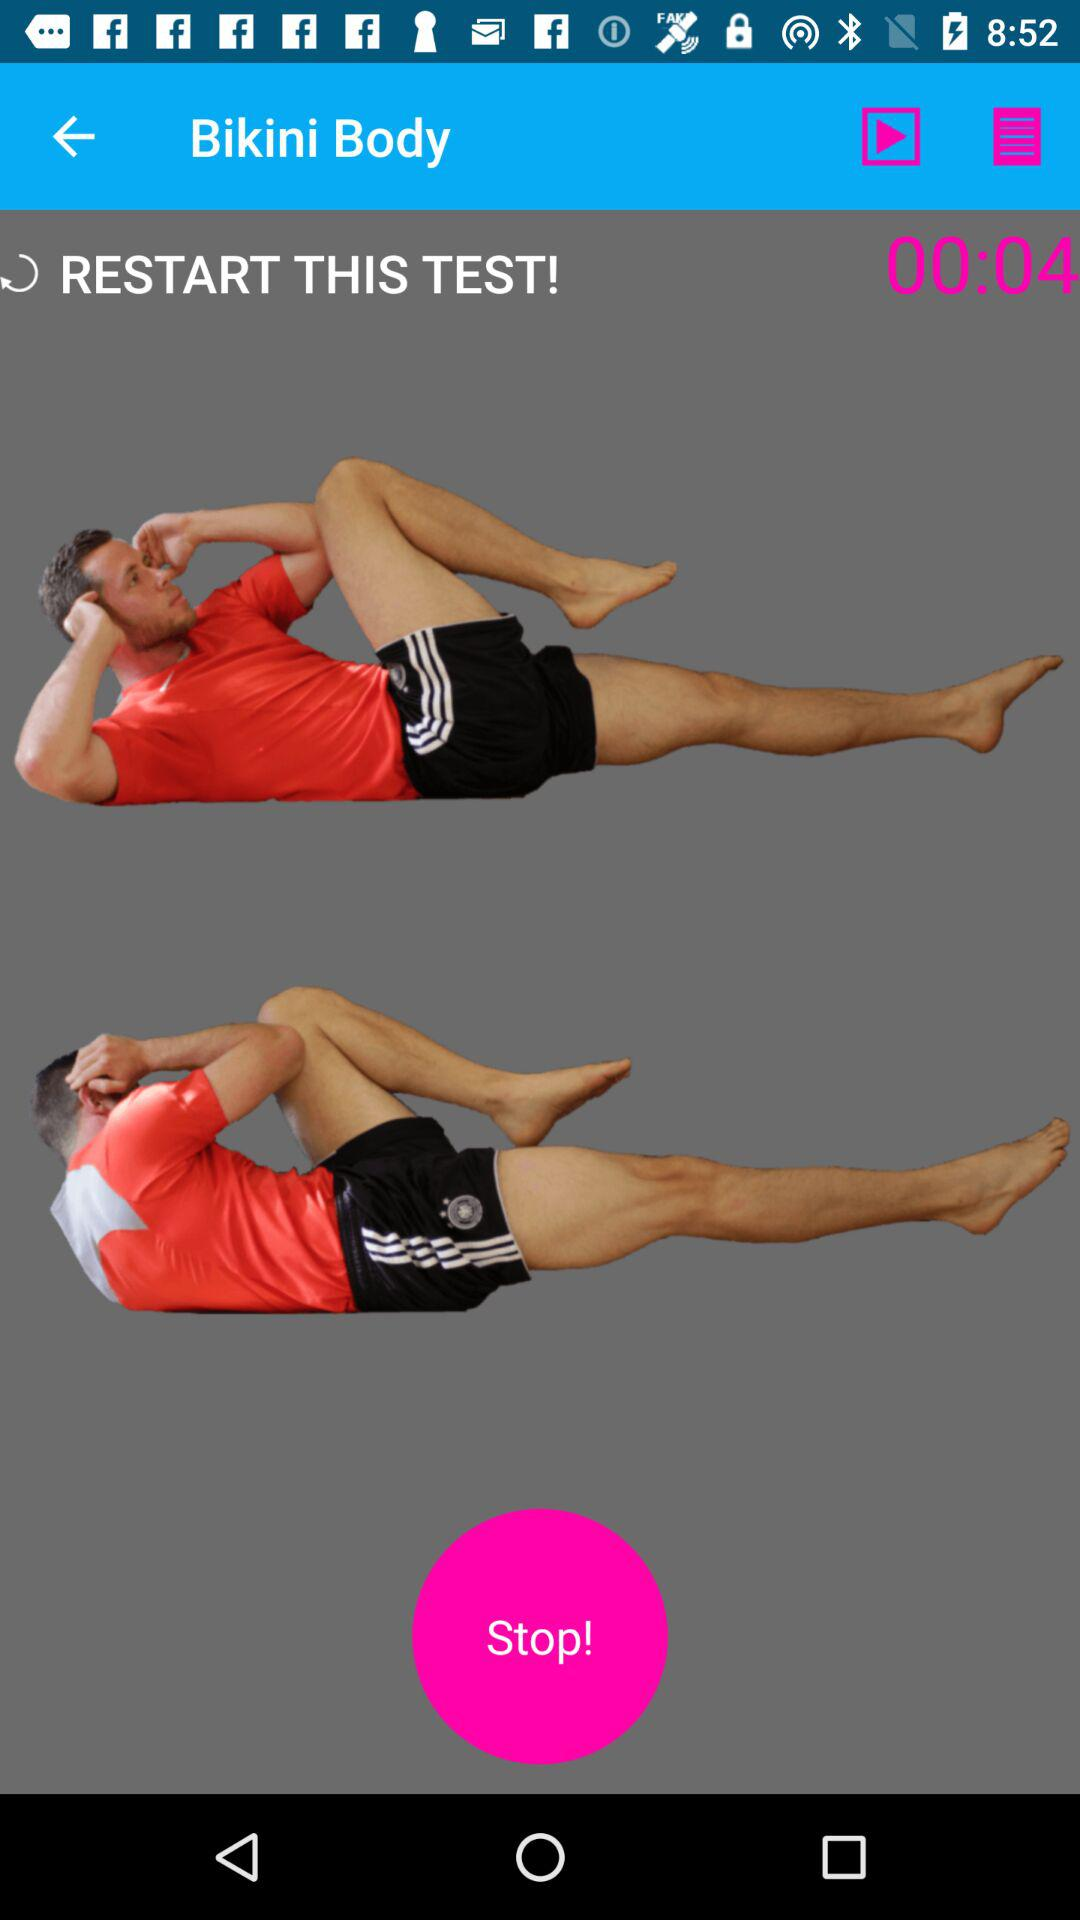What is the mentioned time duration? The mentioned time duration is 4 seconds. 